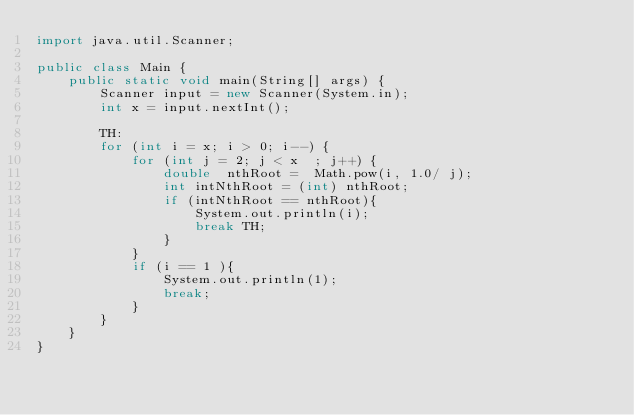Convert code to text. <code><loc_0><loc_0><loc_500><loc_500><_Java_>import java.util.Scanner;

public class Main {
    public static void main(String[] args) {
        Scanner input = new Scanner(System.in);
        int x = input.nextInt();

        TH:
        for (int i = x; i > 0; i--) {
            for (int j = 2; j < x  ; j++) {
                double  nthRoot =  Math.pow(i, 1.0/ j);
                int intNthRoot = (int) nthRoot;
                if (intNthRoot == nthRoot){
                    System.out.println(i);
                    break TH;
                }
            }
            if (i == 1 ){
                System.out.println(1);
                break;
            }
        }
    }
}
</code> 